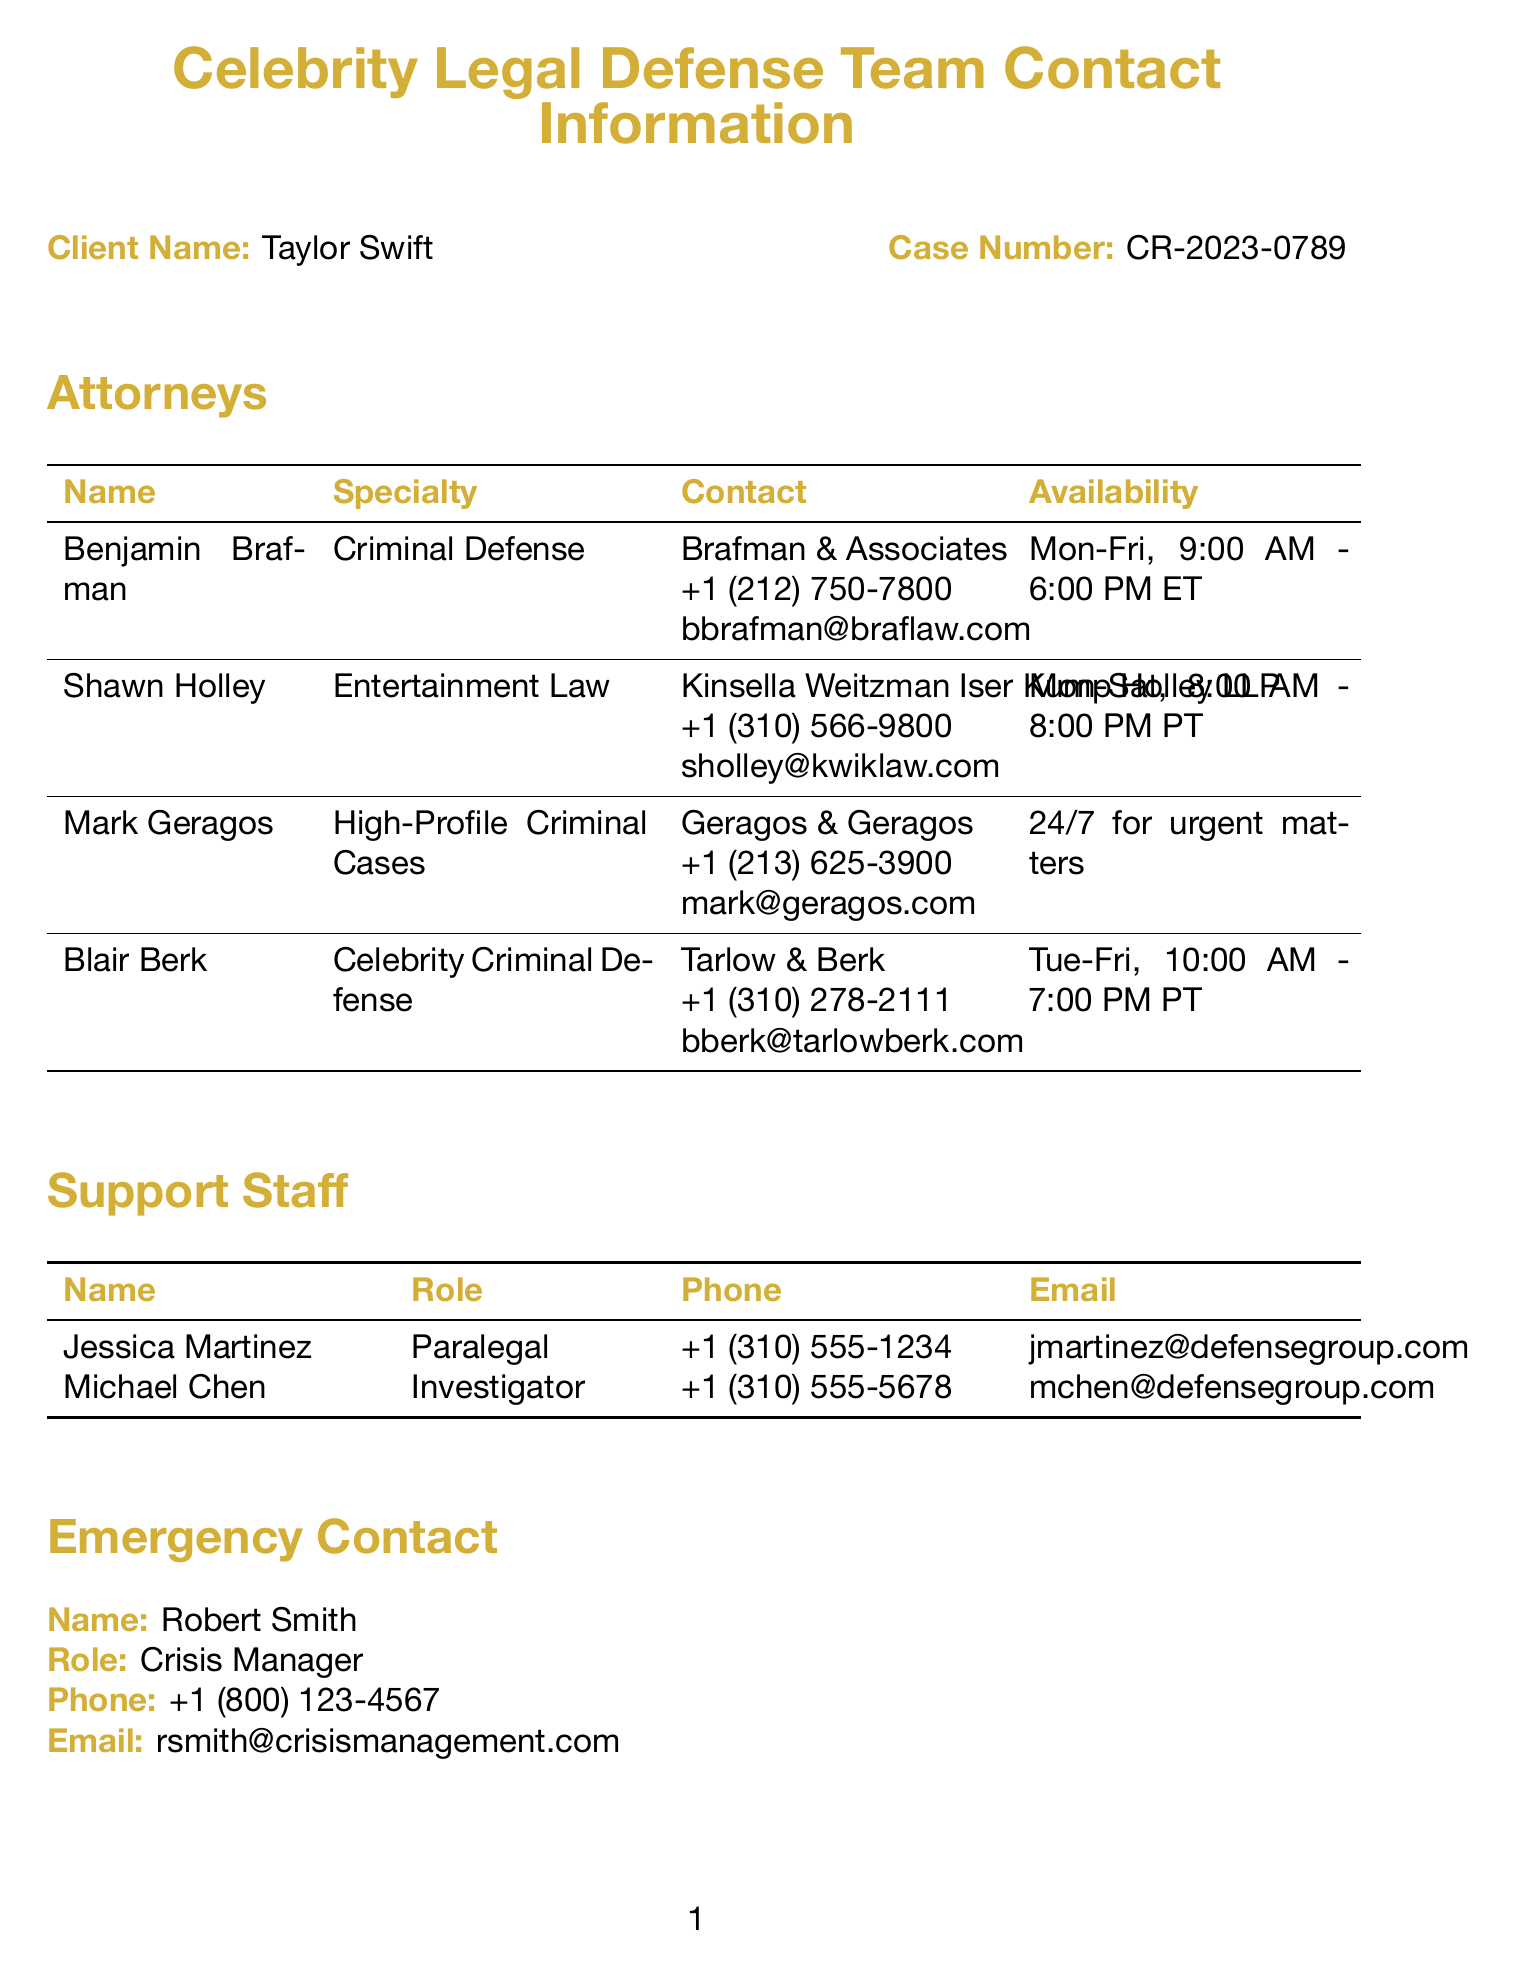What is the client name? The client's name is stated at the beginning of the document under "Client Name."
Answer: Taylor Swift Who is the attorney specializing in Celebrity Criminal Defense? The document lists attorneys and their specialties, identifying Blair Berk as the one specializing in Celebrity Criminal Defense.
Answer: Blair Berk What is the phone number for Mark Geragos? Mark Geragos's contact information includes his phone number located in the attorney's section of the document.
Answer: +1 (213) 625-3900 What days is Shawn Holley available? Shawn Holley's availability is mentioned specifically in the document and includes the days of the week he is available.
Answer: Mon-Sat Who manages crisis situations for the legal team? The emergency contact section names the person responsible for crisis management.
Answer: Robert Smith What is the address of the court? The court's address is detailed in the court information section, specifying where it is located.
Answer: 210 W Temple St, Los Angeles, CA 90012 When is the next court date? The next court date is explicitly stated in the document under the section for future court information.
Answer: 2023-09-15 What is the email address for Jessica Martinez? Jessica Martinez's email address is provided in the support staff section of the document.
Answer: jmartinez@defensegroup.com How often is Mark Geragos available? The document specifies Mark Geragos's availability in relation to urgent matters requiring immediate attention.
Answer: 24/7 for urgent matters 